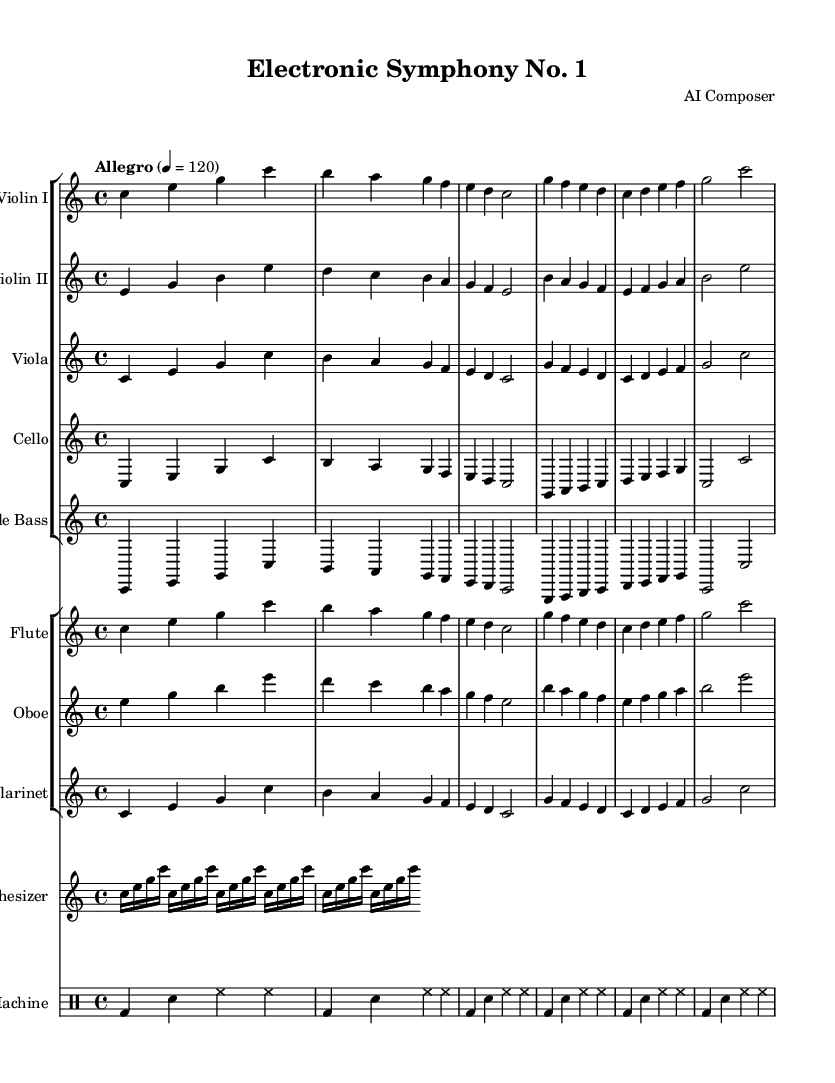What is the key signature of this music? The key signature is C major, which has no sharps or flats.
Answer: C major What is the time signature of this music? The time signature is found at the beginning of the score, indicated as 4/4, meaning there are four beats per measure.
Answer: 4/4 What is the tempo marking of this symphony? The tempo marking is also indicated at the beginning, with the word "Allegro" and a metronome marking of 120 beats per minute, meaning a fast tempo.
Answer: Allegro 4 = 120 How many total instrumental parts are there in this composition? There are five different string instrument parts, three woodwind parts, a synthesizer, and a drum machine, resulting in a total of nine instrumental parts.
Answer: Nine Which instrument has a repeating figure composed of sixteenth notes? The synthesizer part contains a repeating figure with sixteenth notes, specifically the notes C, E, and G, repeated in a rhythmic pattern.
Answer: Synthesizer What percussion instrument is featured in this symphony? The drum machine is the percussion instrument, providing rhythm using bass drums, snare, and hi-hats in its part.
Answer: Drum machine What is the final note value of the cello part? The cello part ends with a whole note, indicated by the symbol; this shows the sustained sound at the end of the piece.
Answer: Whole note 